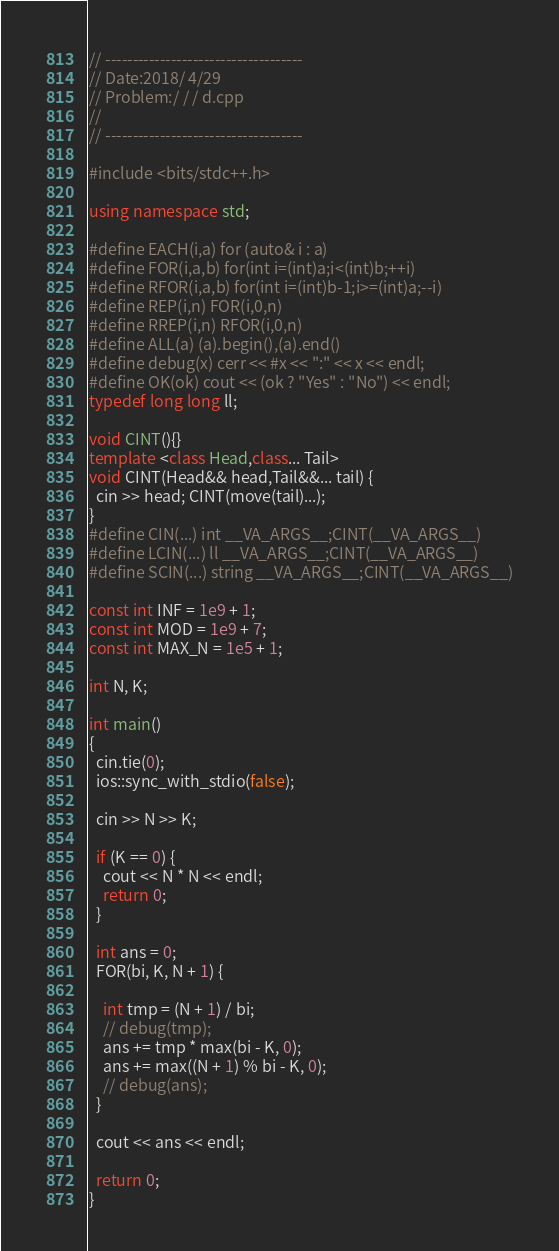Convert code to text. <code><loc_0><loc_0><loc_500><loc_500><_C++_>// ------------------------------------
// Date:2018/ 4/29
// Problem:/ / / d.cpp
//
// ------------------------------------

#include <bits/stdc++.h>

using namespace std;

#define EACH(i,a) for (auto& i : a)
#define FOR(i,a,b) for(int i=(int)a;i<(int)b;++i)
#define RFOR(i,a,b) for(int i=(int)b-1;i>=(int)a;--i)
#define REP(i,n) FOR(i,0,n)
#define RREP(i,n) RFOR(i,0,n)
#define ALL(a) (a).begin(),(a).end()
#define debug(x) cerr << #x << ":" << x << endl;
#define OK(ok) cout << (ok ? "Yes" : "No") << endl;
typedef long long ll;

void CINT(){}
template <class Head,class... Tail>
void CINT(Head&& head,Tail&&... tail) {
  cin >> head; CINT(move(tail)...);
}
#define CIN(...) int __VA_ARGS__;CINT(__VA_ARGS__)
#define LCIN(...) ll __VA_ARGS__;CINT(__VA_ARGS__)
#define SCIN(...) string __VA_ARGS__;CINT(__VA_ARGS__)

const int INF = 1e9 + 1;
const int MOD = 1e9 + 7;
const int MAX_N = 1e5 + 1;

int N, K;

int main()
{
  cin.tie(0);
  ios::sync_with_stdio(false);

  cin >> N >> K;

  if (K == 0) {
    cout << N * N << endl;
    return 0;
  }
  
  int ans = 0;
  FOR(bi, K, N + 1) {

    int tmp = (N + 1) / bi;
    // debug(tmp);
    ans += tmp * max(bi - K, 0);
    ans += max((N + 1) % bi - K, 0);
    // debug(ans);
  }

  cout << ans << endl;

  return 0;
}

</code> 